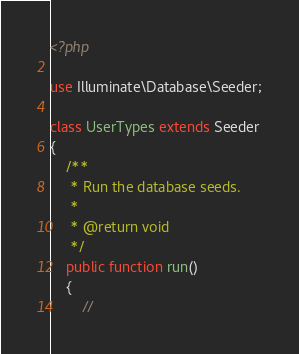Convert code to text. <code><loc_0><loc_0><loc_500><loc_500><_PHP_><?php

use Illuminate\Database\Seeder;

class UserTypes extends Seeder
{
    /**
     * Run the database seeds.
     *
     * @return void
     */
    public function run()
    {
        //     
</code> 